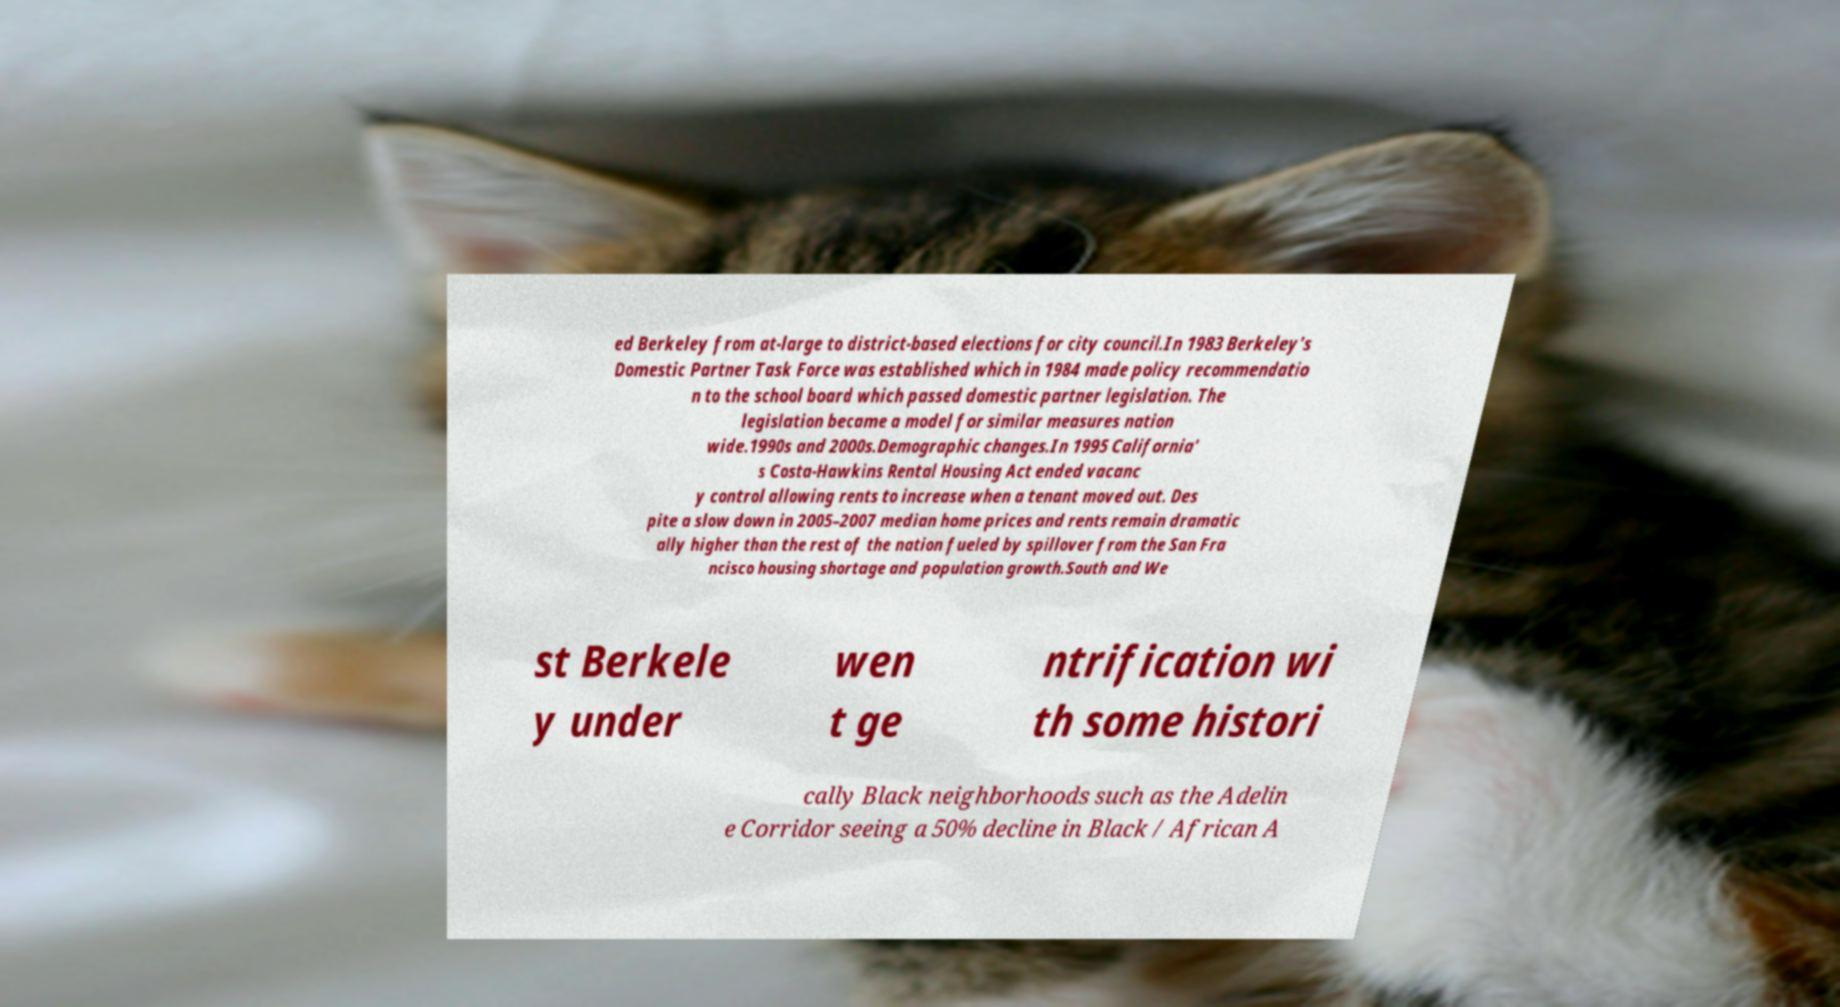There's text embedded in this image that I need extracted. Can you transcribe it verbatim? ed Berkeley from at-large to district-based elections for city council.In 1983 Berkeley's Domestic Partner Task Force was established which in 1984 made policy recommendatio n to the school board which passed domestic partner legislation. The legislation became a model for similar measures nation wide.1990s and 2000s.Demographic changes.In 1995 California' s Costa-Hawkins Rental Housing Act ended vacanc y control allowing rents to increase when a tenant moved out. Des pite a slow down in 2005–2007 median home prices and rents remain dramatic ally higher than the rest of the nation fueled by spillover from the San Fra ncisco housing shortage and population growth.South and We st Berkele y under wen t ge ntrification wi th some histori cally Black neighborhoods such as the Adelin e Corridor seeing a 50% decline in Black / African A 